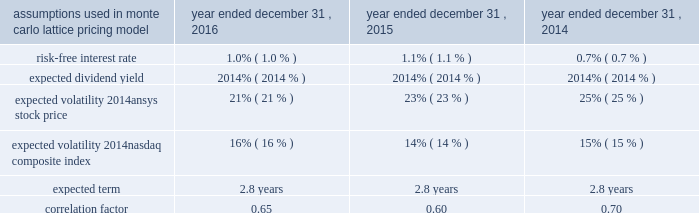Table of contents .
The company issued 35000 , 115485 and 39900 performance-based restricted stock awards during 2016 , 2015 and 2014 , respectively .
Of the cumulative performance-based restricted stock awards issued , defined operating metrics were assigned to 63462 , 51795 and 20667 awards with grant-date fair values of $ 84.61 , $ 86.38 and $ 81.52 during 2016 , 2015 and 2014 , respectively .
The grant-date fair value of the awards is being recorded from the grant date through the conclusion of the measurement period associated with each operating metric based on management's estimates concerning the probability of vesting .
As of december 31 , 2016 , 7625 units of the total 2014 awards granted were earned and will be issued in 2017 .
Total compensation expense associated with the awards recorded for the years ended december 31 , 2016 , 2015 and 2014 was $ 0.4 million , $ 0.4 million and $ 0.1 million , respectively .
In addition , in 2016 , 2015 and 2014 , the company granted restricted stock units of 488622 , 344500 and 364150 , respectively , that will vest over a three- or four-year period with weighted-average grant-date fair values of $ 88.51 , $ 86.34 and $ 82.13 , respectively .
During 2016 and 2015 , 162019 and 85713 shares vested and were released , respectively .
As of december 31 , 2016 , 2015 and 2014 , 838327 , 571462 and 344750 units were outstanding , respectively .
Total compensation expense is being recorded over the service period and was $ 19.1 million , $ 12.5 million and $ 5.8 million for the years ended december 31 , 2016 , 2015 and 2014 , respectively .
In conjunction with a 2015 acquisition , ansys issued 68451 shares of replacement restricted stock with a weighted-average grant-date fair value of $ 90.48 .
Of the $ 6.2 million grant-date fair value , $ 3.5 million , related to partially vested awards , was recorded as non-cash purchase price consideration .
The remaining fair value will be recognized as stock compensation expense through the conclusion of the service period .
During the years ended december 31 , 2016 and 2015 , the company recorded $ 1.2 million and $ 0.6 million , respectively , of stock compensation expense related to these awards .
In conjunction with a 2011 acquisition , the company granted performance-based restricted stock awards .
Vesting was determined based on the achievements of certain revenue and operating income targets of the entity post-acquisition .
Total compensation expense associated with the awards recorded for the year ended december 31 , 2014 was $ 4.7 million .
The company has granted deferred stock awards to non-affiliate independent directors , which are rights to receive shares of common stock upon termination of service as a director .
In 2015 and prior , the deferred stock awards were granted quarterly in arrears and vested immediately upon grant .
Associated with these awards , the company established a non-qualified 409 ( a ) deferred compensation plan with assets held under a rabbi trust to provide directors an opportunity to diversify their vested awards .
During open trading windows and at their elective option , the directors may convert their company shares into a variety of non-company-stock investment options in order to diversify their holdings .
As of december 31 , 2016 , 5000 shares have been diversified and 184099 undiversified deferred stock awards have vested with the underlying shares remaining unissued until the service termination of the respective director owners .
In may 2016 , the company granted 38400 deferred stock awards which will vest in full on the one-year anniversary of the grant .
Total compensation expense associated with the awards recorded for the years ended december 31 , 2016 , 2015 and 2014 was $ 1.9 million , $ 4.0 million and $ 3.5 million , respectively. .
What was the value of the restricted stock that the company granted in 2016? 
Computations: (488622 * 88.51)
Answer: 43247933.22. 